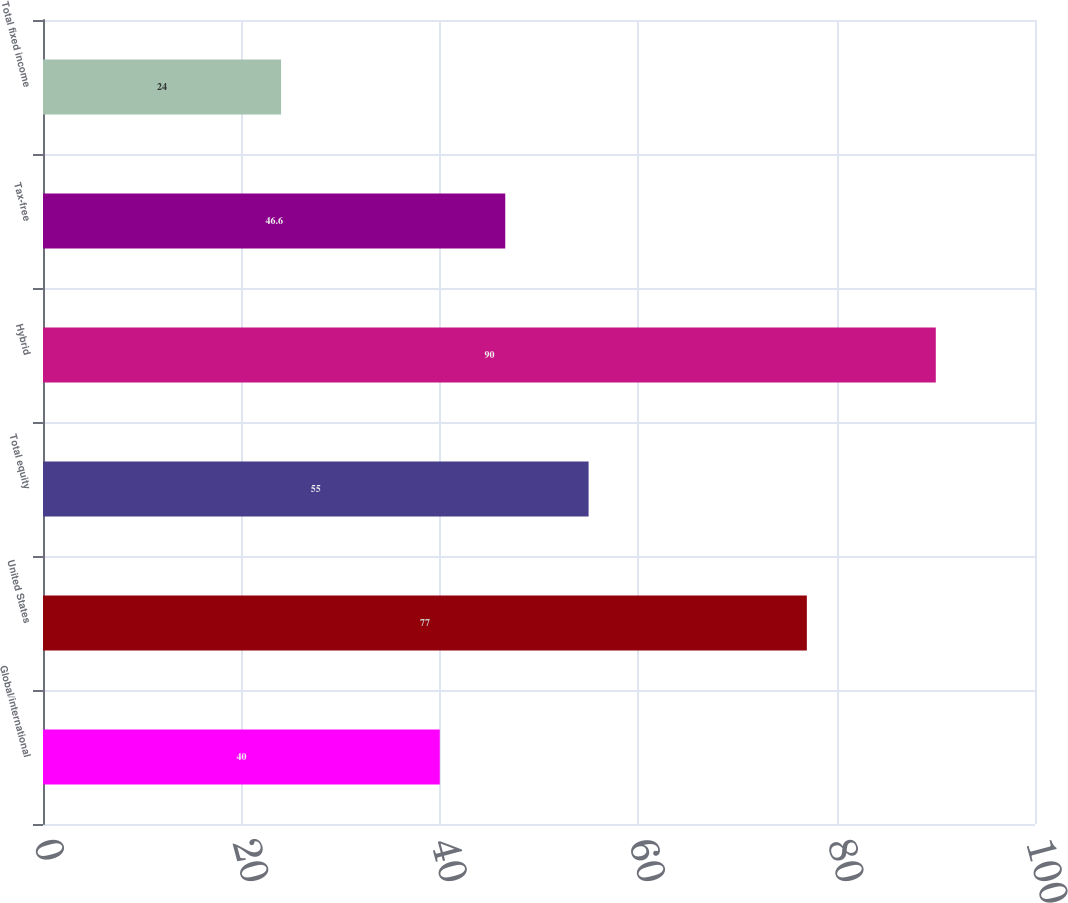<chart> <loc_0><loc_0><loc_500><loc_500><bar_chart><fcel>Global/international<fcel>United States<fcel>Total equity<fcel>Hybrid<fcel>Tax-free<fcel>Total fixed income<nl><fcel>40<fcel>77<fcel>55<fcel>90<fcel>46.6<fcel>24<nl></chart> 